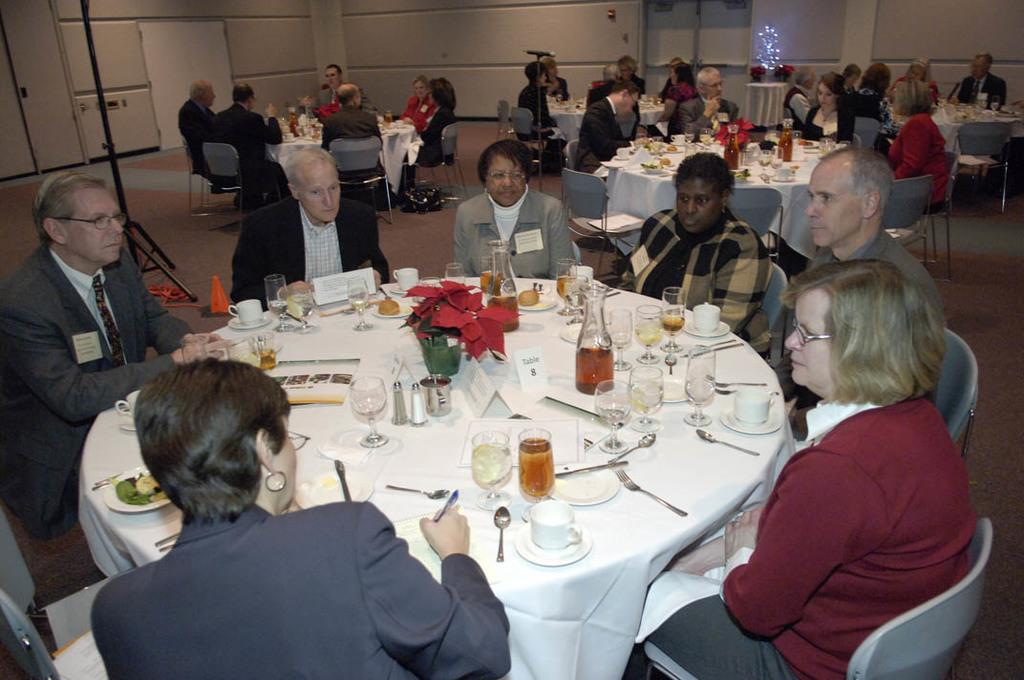How are the people positioned in the image? The people are arranged in a circular way. What is in front of the people? There is a table in front of the people. What items can be seen on the table? There is a wine glass, a spoon, a fork, and a teacup on the table. How many frogs are jumping on the table in the image? There are no frogs present in the image; the table only contains a wine glass, a spoon, a fork, and a teacup. 